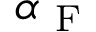Convert formula to latex. <formula><loc_0><loc_0><loc_500><loc_500>\alpha _ { F }</formula> 